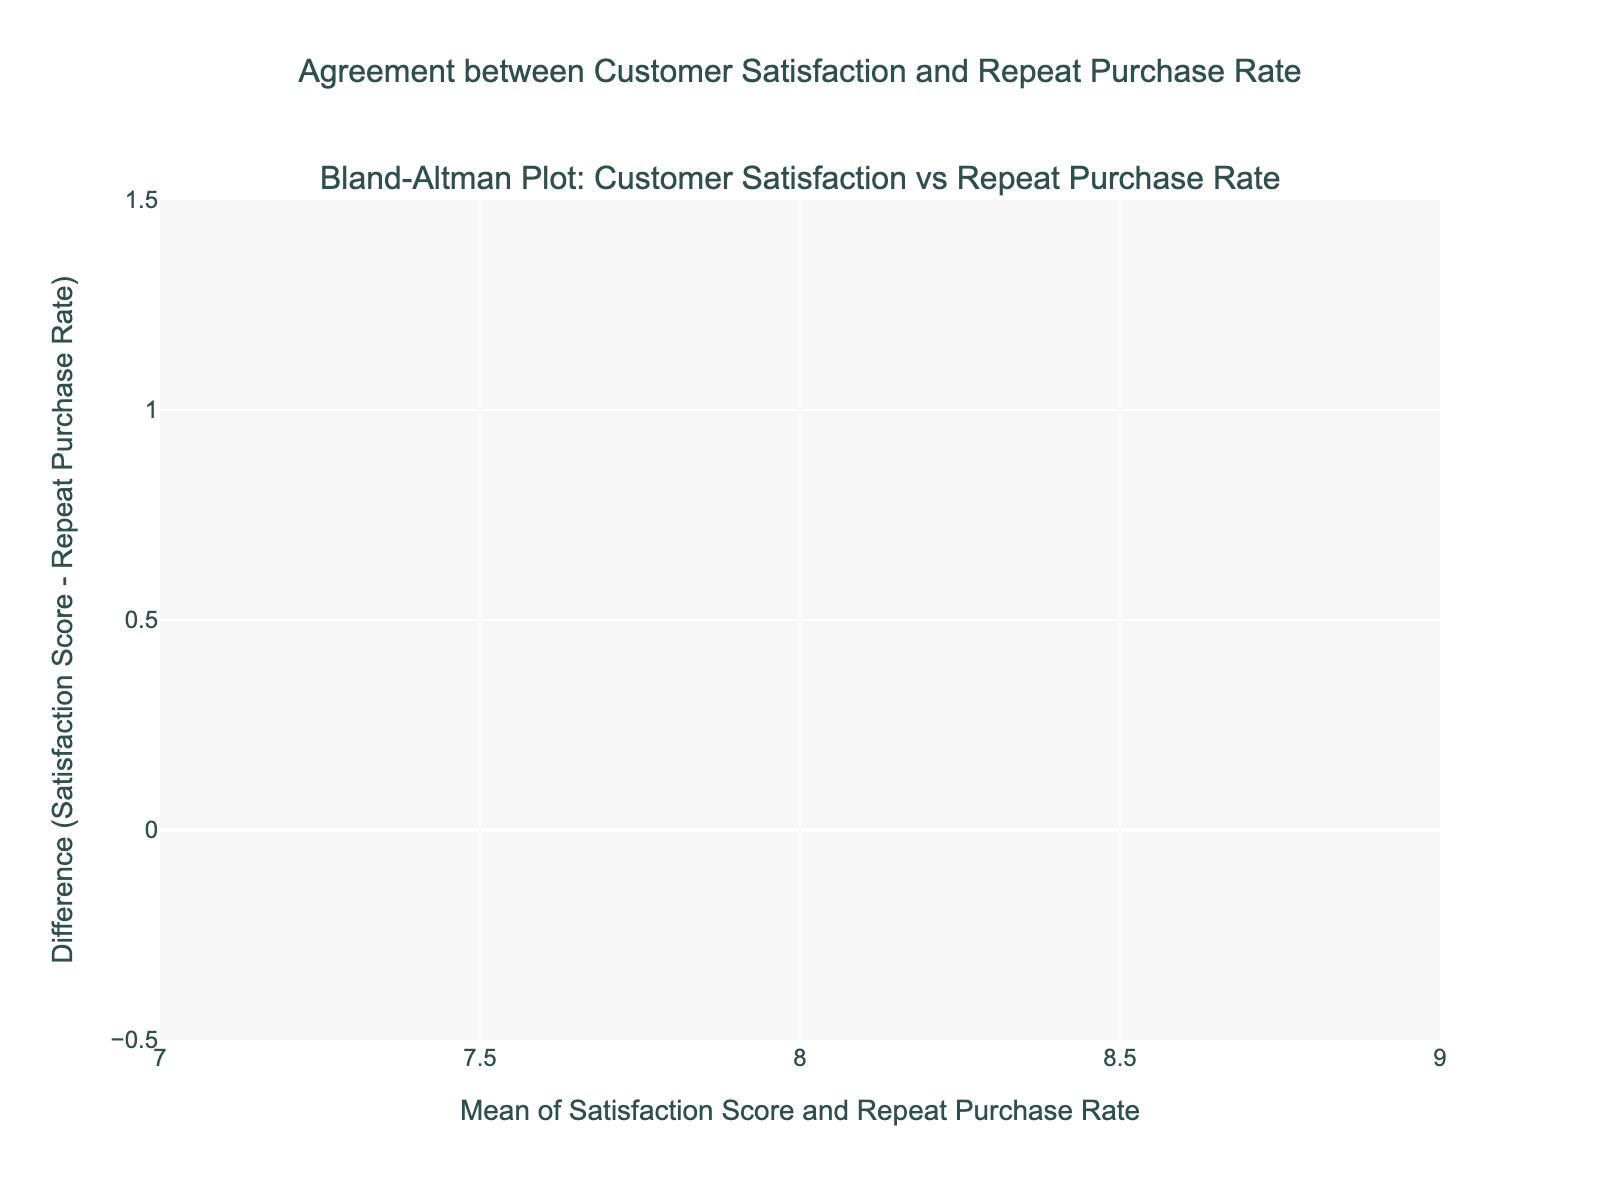Which customer regions have the highest and lowest satisfaction scores? On the plot, we see different customer regions denoted by satisfaction scores. The West Coast Region has the highest satisfaction score of 8.8 while Illinois has the lowest score of 7.5.
Answer: West Coast Region, Illinois What is the title of the plot? The title of the plot is located at the top and reads 'Agreement between Customer Satisfaction and Repeat Purchase Rate'.
Answer: Agreement between Customer Satisfaction and Repeat Purchase Rate How many data points are plotted? From the labels of customer regions on the plot, there are 15 data points displayed.
Answer: 15 What is the mean difference between customer satisfaction scores and repeat purchase rates? The mean difference is denoted by a dashed red line labeled 'Mean' on the plot, which is located on the y-axis at approximately 0.67.
Answer: 0.67 Which regions fall outside the limits of agreement? The limits of agreement are shown by dotted green lines at +1.96 SD and -1.96 SD. The plot shows that no regions fall outside these limits.
Answer: None Are there any regions exactly at the mean difference? The mean difference line is a dashed red line labeled 'Mean' at approximately 0.67. The regions that lie on this line are Florida and California.
Answer: Florida, California What are the upper and lower limits of the agreement? The plot denotes the upper and lower limits with green dotted lines labeled '+1.96 SD' and '-1.96 SD'. The upper limit is around 1.21 and the lower limit is around 0.12.
Answer: Upper: 1.21, Lower: 0.12 What is the average of the satisfaction score and repeat purchase rate for the Northeast Region? The average is calculated by taking the mean of 8.2 (Satisfaction Score) and 0.76 (Repeat Purchase Rate) for the Northeast Region, resulting in (8.2 + 0.76)/2 = 4.48.
Answer: 4.48 Are there any areas where the satisfaction score is much higher than the repeat purchase rate? The difference column in the plot where the satisfaction score substantially exceeds the repeat purchase rate are regions where the points are notably above the mean difference line, such as Illinois.
Answer: Illinois 